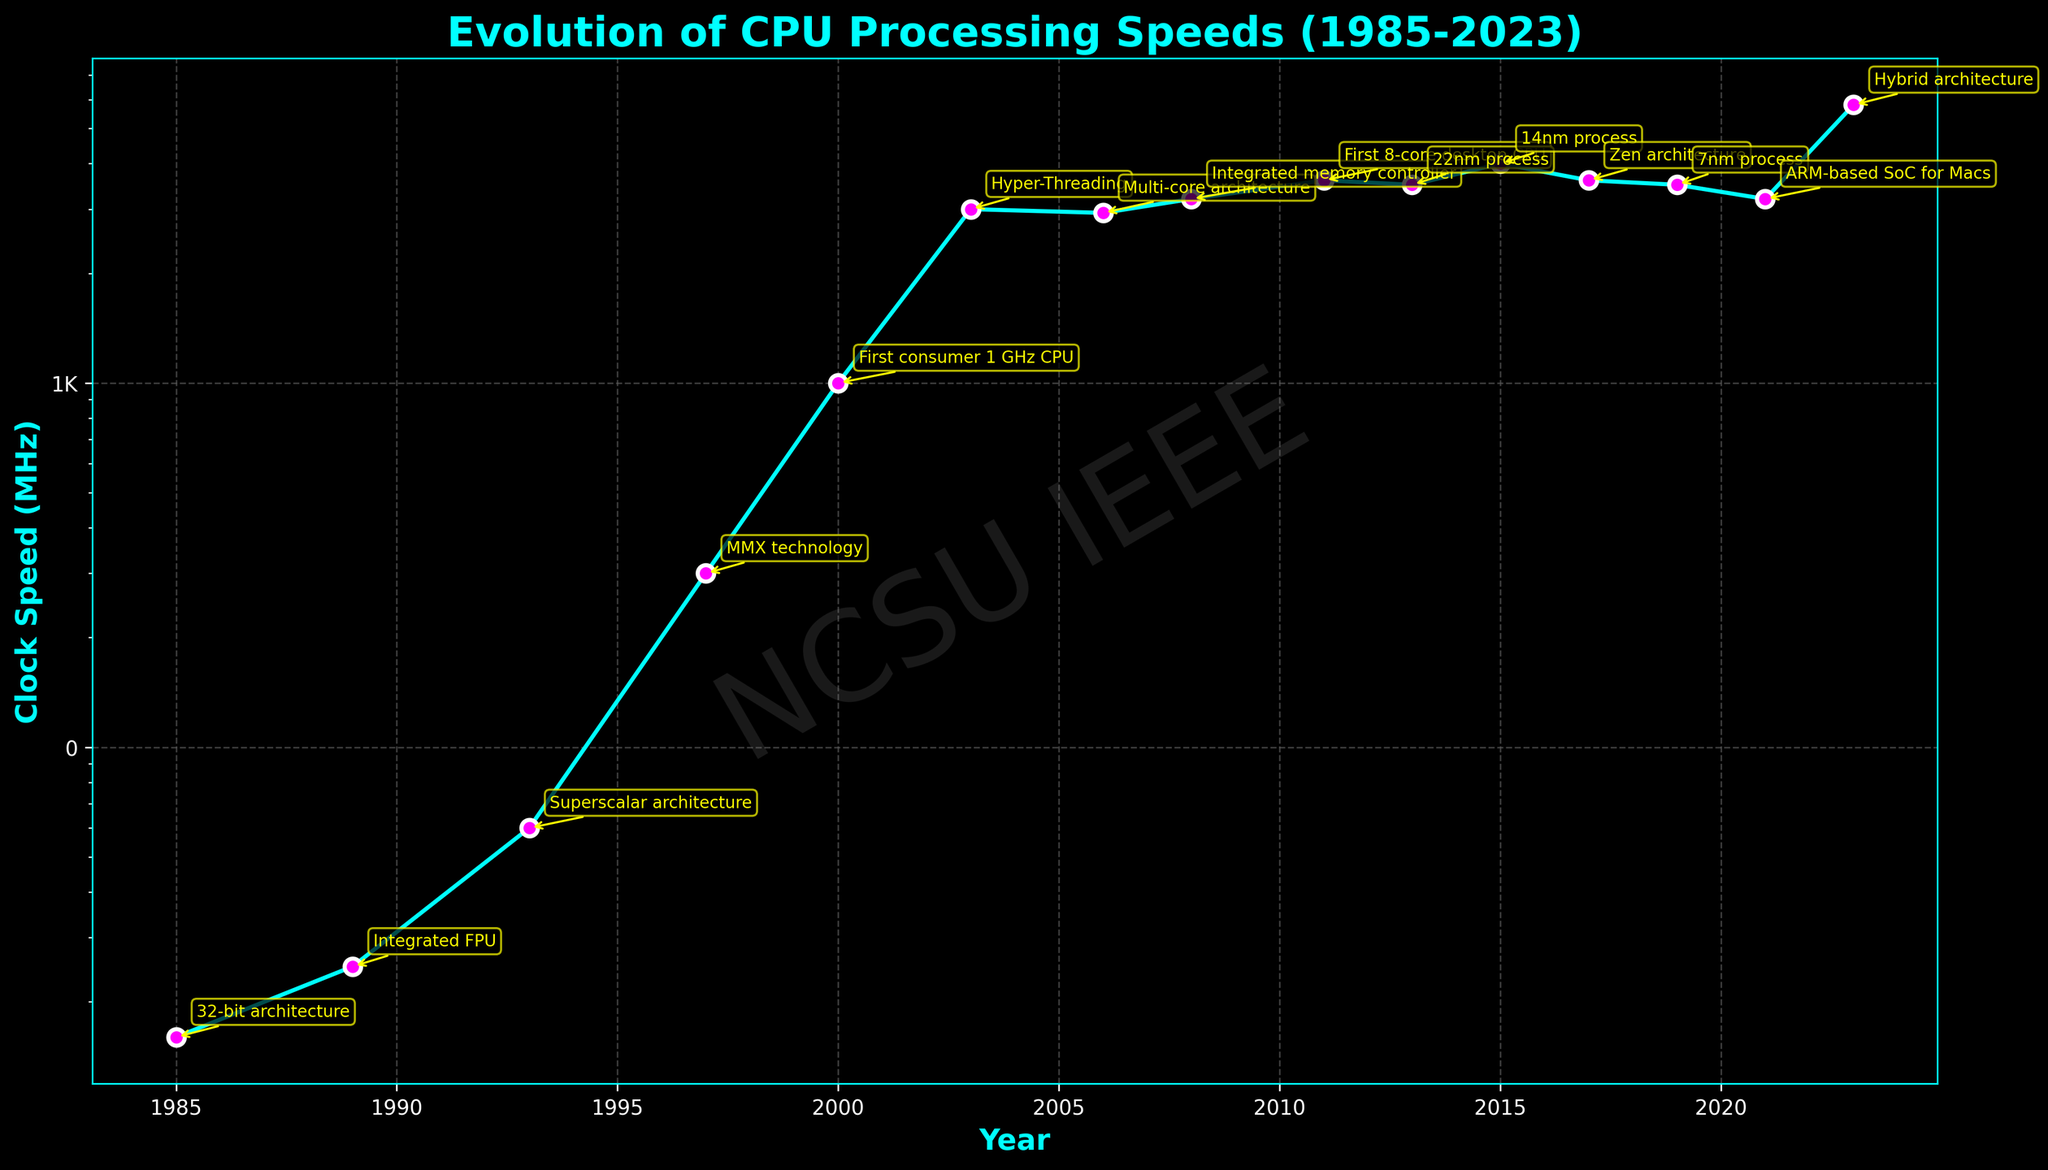What is the highest recorded clock speed in the figure? The highest recorded clock speed is identified by looking for the peak value on the y-axis of the line chart, which is 5800 MHz.
Answer: 5800 MHz Which CPU model first achieved a clock speed of over 1000 MHz? Locate the year and clock speed where the data crosses the 1000 MHz threshold. The figure shows the AMD Athlon reached 1000 MHz in the year 2000.
Answer: AMD Athlon How many notable features are annotated in the figure? Count the number of annotation points marked with notable features along the plotted line. There are 14 different annotations listed.
Answer: 14 Compare the clock speed of the Intel Pentium released in 1993 with the AMD Ryzen 9 3950X released in 2019. Which one is higher, and by how much? From the figure, identify the clock speeds for both CPUs. The Intel Pentium has a clock speed of 60 MHz, and the AMD Ryzen 9 3950X is 3500 MHz. The difference is 3500 MHz - 60 MHz.
Answer: AMD Ryzen 9 3950X by 3440 MHz Which year had a greater clock speed improvement compared to its predecessor: 1997 or 2003? Compare the increments by finding the difference in clock speeds between the year 1997 and its previous model (300 MHz - 60 MHz) and 2003 and its previous model (3000 MHz - 1000 MHz). The improvement in 2003 (2000 MHz) is greater than 1997 (240 MHz).
Answer: 2003 What is the earliest year where a CPU model featured a multi-core architecture? Refer to the annotations for notable features and identify the first instance mentioning a multi-core architecture, which occurred with the Intel Core 2 Duo in 2006.
Answer: 2006 What visual attribute indicates notable features in the figure? In the plot, the annotations for notable features are highlighted with text boxes and arrows pointing to specific data points.
Answer: text boxes and arrows Identify the CPU model that marked the transition to a 7nm process technology and its clock speed. Check the annotations for mentions of 7nm process technology, which corresponds to the AMD Ryzen 9 3950X with a clock speed of 3500 MHz.
Answer: AMD Ryzen 9 3950X, 3500 MHz How long did it take for CPU clock speeds to exceed 3000 MHz from the first recorded data point in 1985? Determine the difference in years between when the first CPU was noted (1985) and when clock speeds exceeded 3000 MHz (2003). It took 2003 - 1985.
Answer: 18 years 